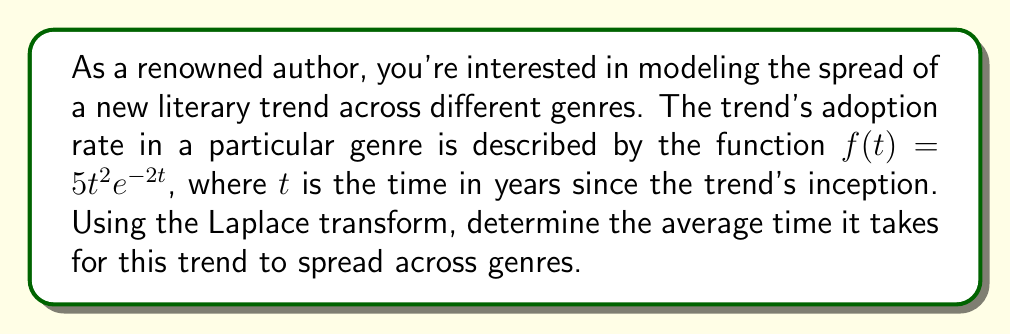What is the answer to this math problem? To solve this problem, we'll follow these steps:

1) First, we need to find the Laplace transform of $f(t)$. The Laplace transform of $f(t)$ is defined as:

   $$F(s) = \mathcal{L}\{f(t)\} = \int_0^\infty f(t)e^{-st}dt$$

2) In our case, $f(t) = 5t^2e^{-2t}$. So we need to calculate:

   $$F(s) = 5\int_0^\infty t^2e^{-2t}e^{-st}dt = 5\int_0^\infty t^2e^{-(s+2)t}dt$$

3) This integral can be solved using the general formula for the Laplace transform of $t^n e^{at}$:

   $$\mathcal{L}\{t^n e^{at}\} = \frac{n!}{(s-a)^{n+1}}$$

4) In our case, $n=2$ and $a=-2$. Substituting these values:

   $$F(s) = 5 \cdot \frac{2!}{(s+2)^{2+1}} = \frac{10}{(s+2)^3}$$

5) To find the average time, we need to calculate the expected value of $t$. In the time domain, this would be:

   $$E[t] = \frac{\int_0^\infty tf(t)dt}{\int_0^\infty f(t)dt}$$

6) In the s-domain, this is equivalent to:

   $$E[t] = -\frac{F'(0)}{F(0)}$$

   where $F'(s)$ is the derivative of $F(s)$ with respect to $s$.

7) Let's calculate $F'(s)$:

   $$F'(s) = -\frac{30}{(s+2)^4}$$

8) Now we can calculate $E[t]$:

   $$E[t] = -\frac{F'(0)}{F(0)} = -\frac{-30/2^4}{10/2^3} = \frac{15}{10} = \frac{3}{2}$$

Therefore, the average time for the trend to spread across genres is 1.5 years.
Answer: The average time for the literary trend to spread across genres is $\frac{3}{2}$ or 1.5 years. 